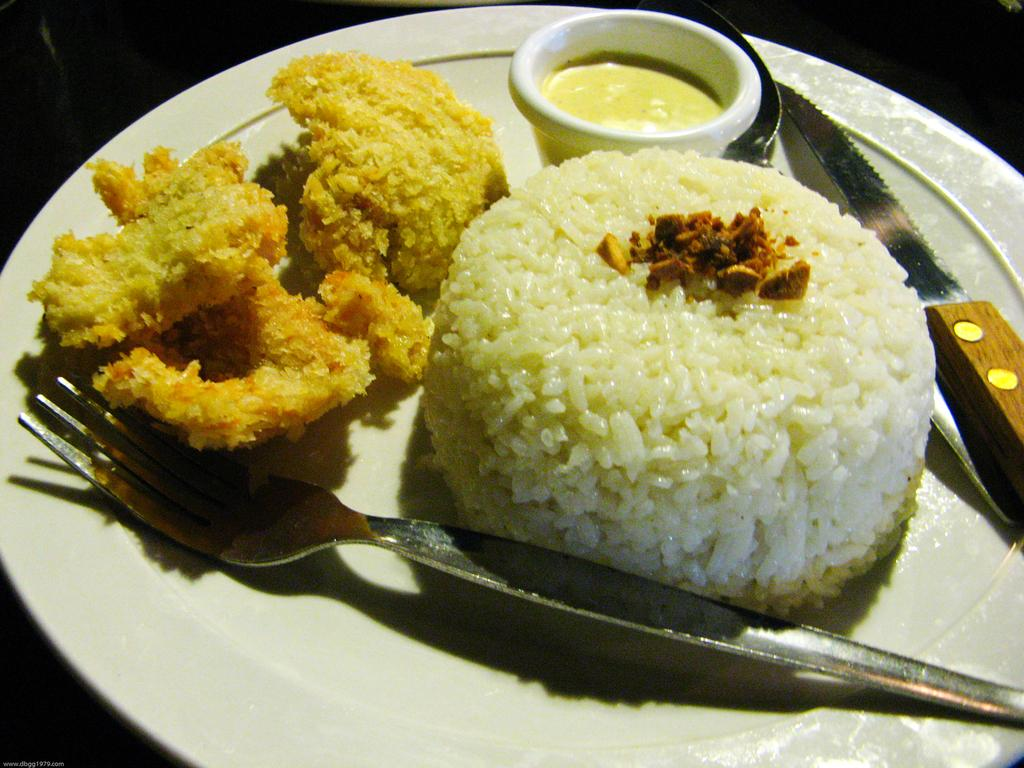What type of food can be seen in the image? There is food in the image, but the specific type is not mentioned. What utensil is present in the image? There is a knife in the image. What is contained in the bowl in the image? There is a liquid in a bowl in the image. What is placed on the plate in the image? There is a fork on a plate in the image. What color is the background of the image? The background of the image is black. How many chickens are visible in the image? There are no chickens present in the image. What type of can is shown in the image? There is no can present in the image. What type of teeth can be seen in the image? There are no teeth visible in the image. 